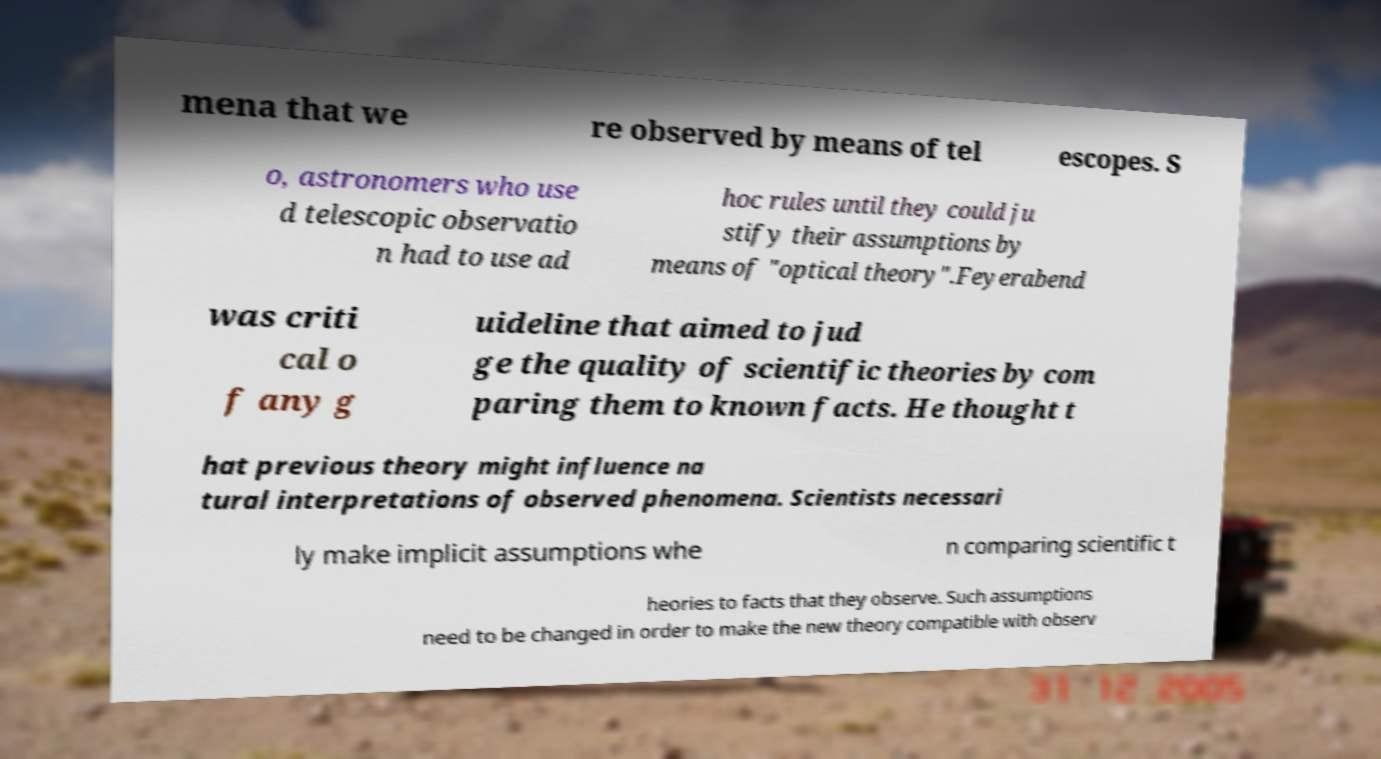What messages or text are displayed in this image? I need them in a readable, typed format. mena that we re observed by means of tel escopes. S o, astronomers who use d telescopic observatio n had to use ad hoc rules until they could ju stify their assumptions by means of "optical theory".Feyerabend was criti cal o f any g uideline that aimed to jud ge the quality of scientific theories by com paring them to known facts. He thought t hat previous theory might influence na tural interpretations of observed phenomena. Scientists necessari ly make implicit assumptions whe n comparing scientific t heories to facts that they observe. Such assumptions need to be changed in order to make the new theory compatible with observ 